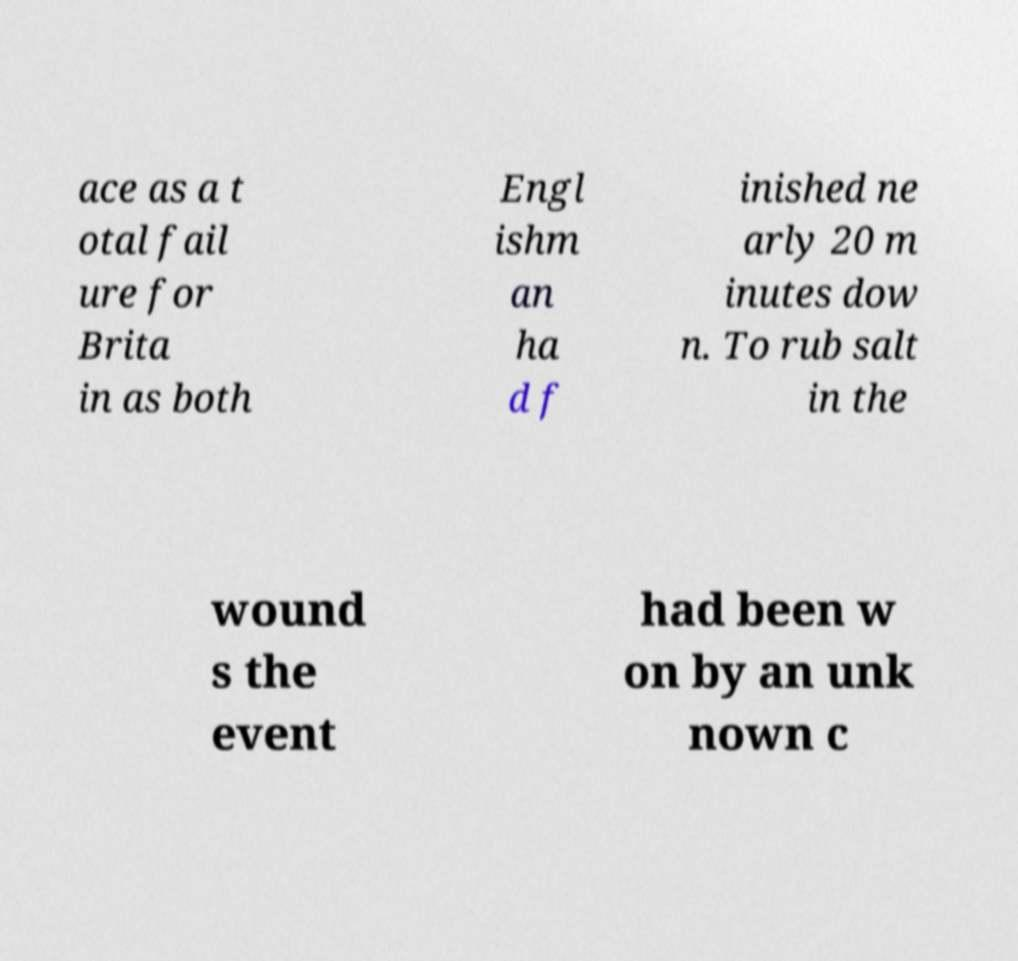Can you accurately transcribe the text from the provided image for me? ace as a t otal fail ure for Brita in as both Engl ishm an ha d f inished ne arly 20 m inutes dow n. To rub salt in the wound s the event had been w on by an unk nown c 